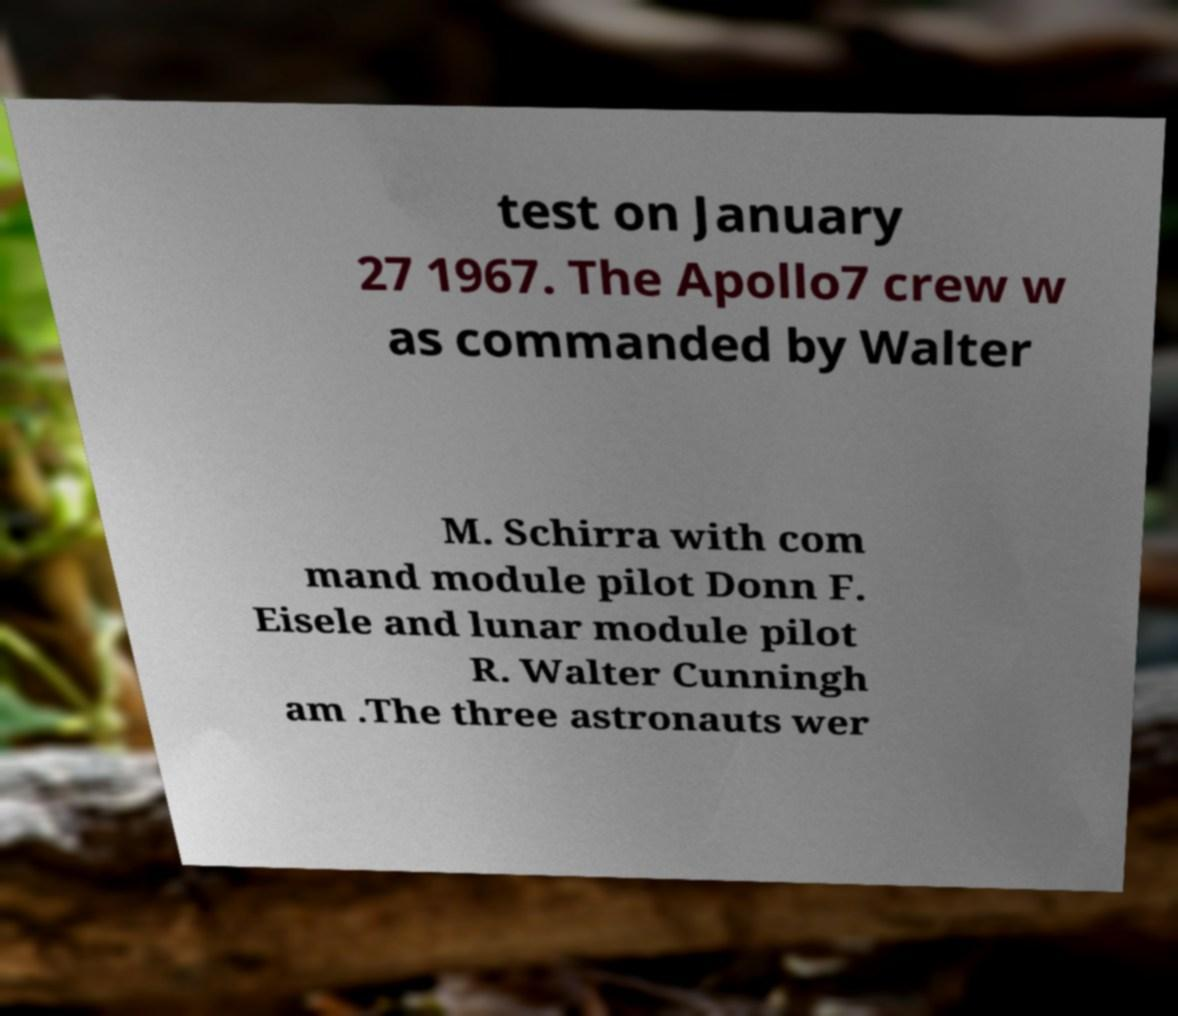Can you accurately transcribe the text from the provided image for me? test on January 27 1967. The Apollo7 crew w as commanded by Walter M. Schirra with com mand module pilot Donn F. Eisele and lunar module pilot R. Walter Cunningh am .The three astronauts wer 